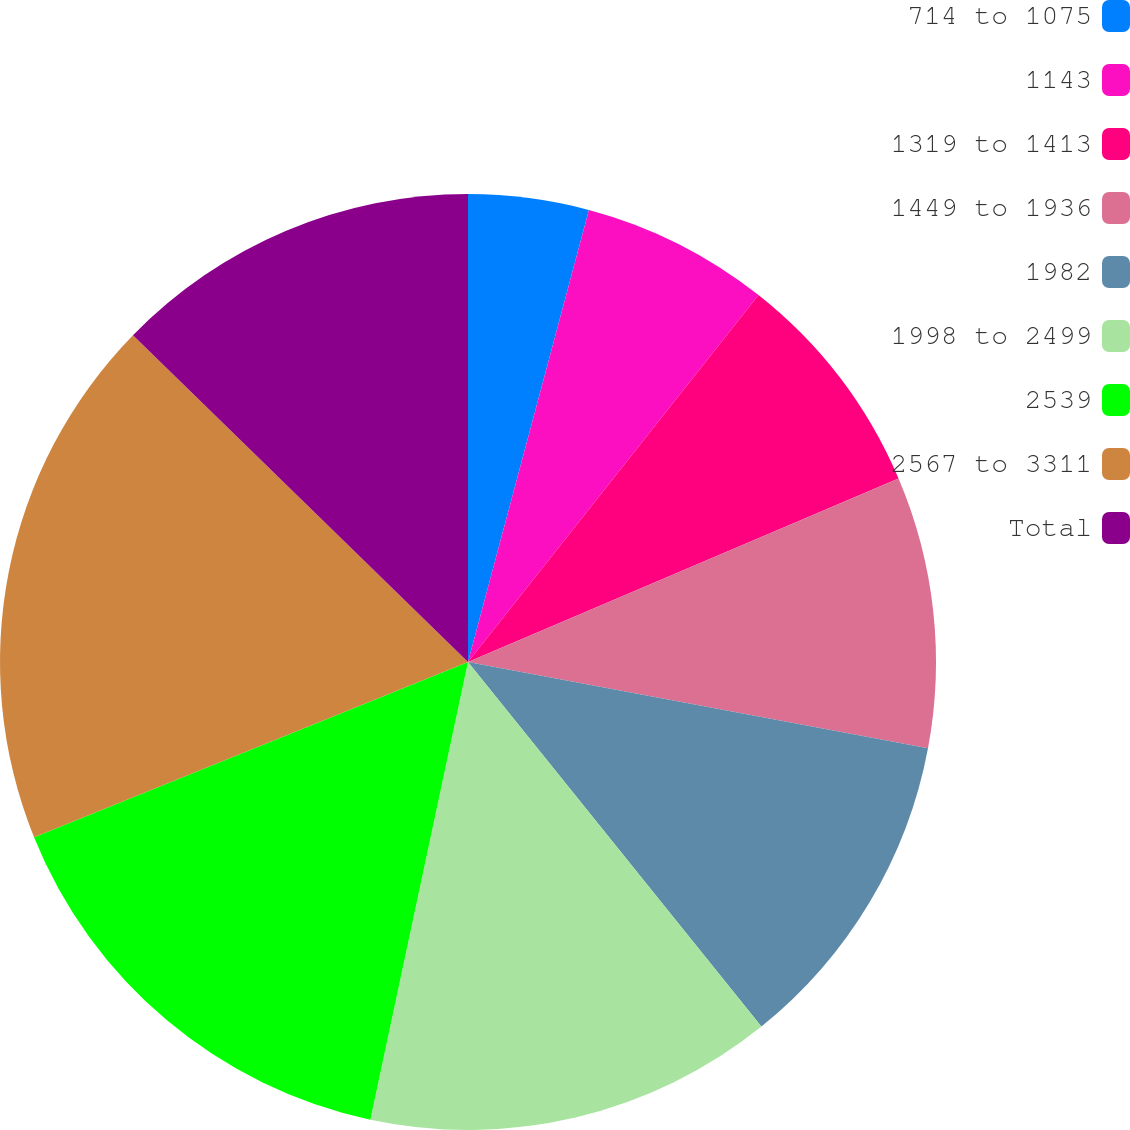Convert chart to OTSL. <chart><loc_0><loc_0><loc_500><loc_500><pie_chart><fcel>714 to 1075<fcel>1143<fcel>1319 to 1413<fcel>1449 to 1936<fcel>1982<fcel>1998 to 2499<fcel>2539<fcel>2567 to 3311<fcel>Total<nl><fcel>4.16%<fcel>6.5%<fcel>7.93%<fcel>9.36%<fcel>11.27%<fcel>14.13%<fcel>15.55%<fcel>18.41%<fcel>12.7%<nl></chart> 